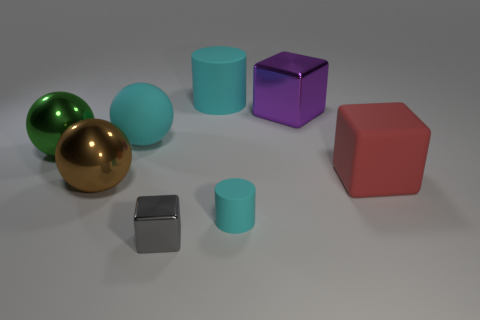Subtract all cubes. How many objects are left? 5 Add 1 small cylinders. How many objects exist? 9 Subtract all big red rubber blocks. How many blocks are left? 2 Subtract 2 cylinders. How many cylinders are left? 0 Add 1 large brown spheres. How many large brown spheres are left? 2 Add 4 small gray cubes. How many small gray cubes exist? 5 Subtract all brown balls. How many balls are left? 2 Subtract 1 gray cubes. How many objects are left? 7 Subtract all green spheres. Subtract all blue blocks. How many spheres are left? 2 Subtract all gray cylinders. How many gray blocks are left? 1 